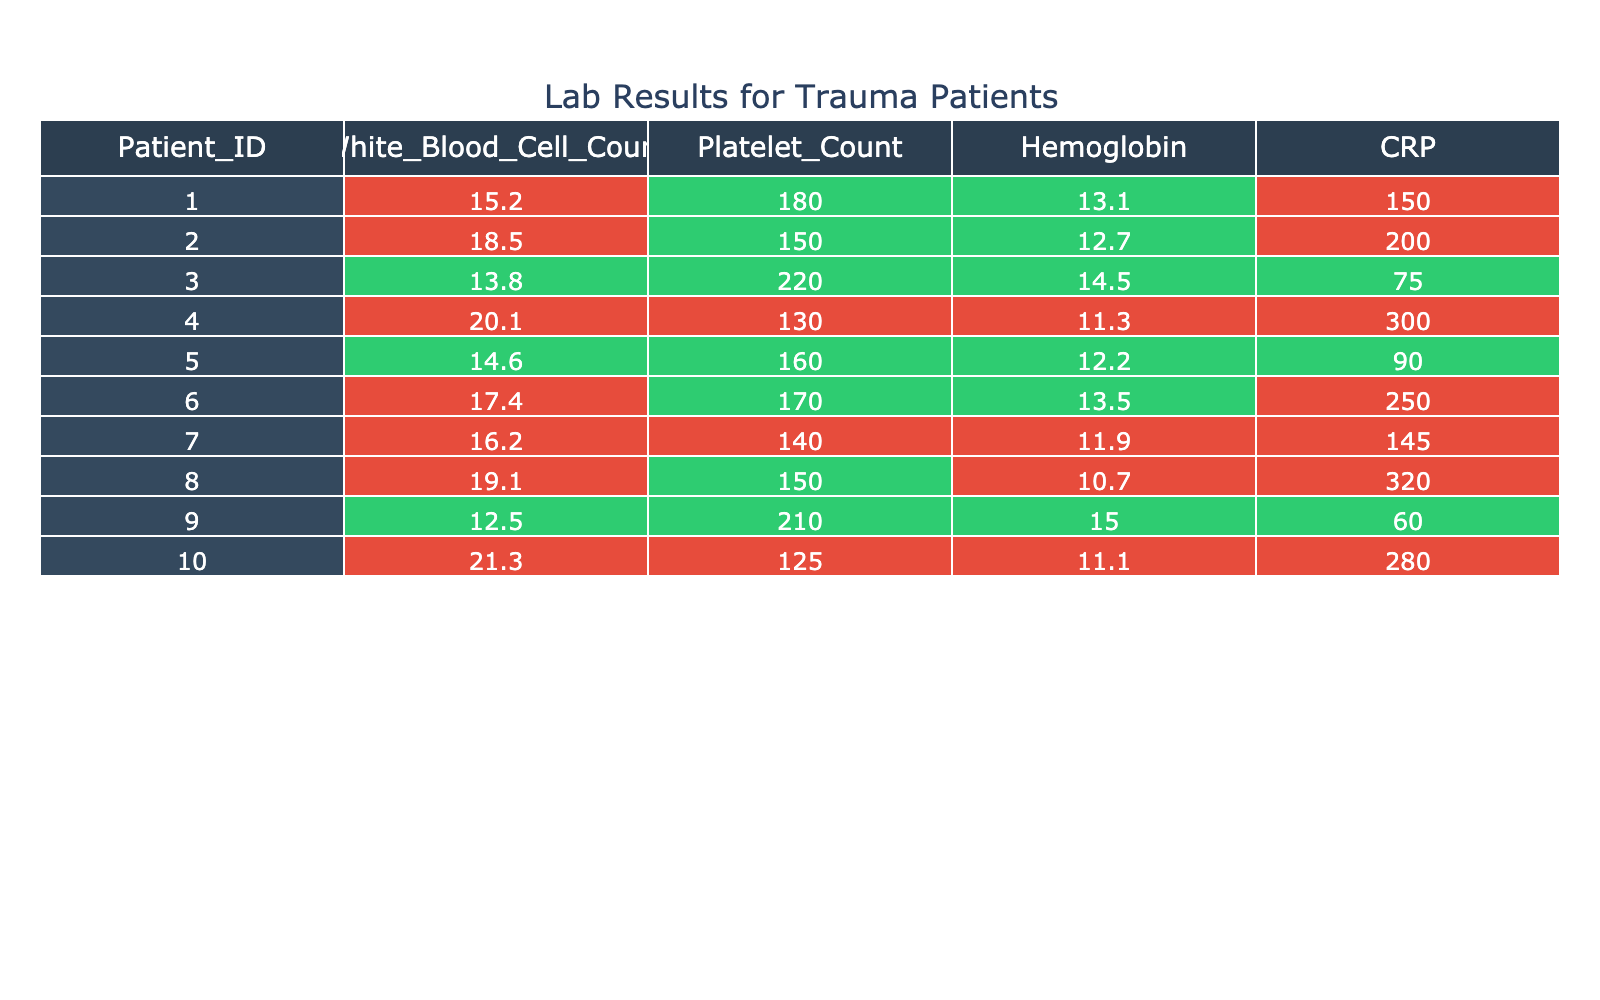What is the White Blood Cell Count for Patient ID 005? The table shows that Patient ID 005 has a White Blood Cell Count of 14.6.
Answer: 14.6 Which patient has the highest CRP value? Upon reviewing the CRP values, Patient ID 004 shows the highest value at 300.
Answer: Patient ID 004 Is there any patient with a Hemoglobin level below 12? By examining the Hemoglobin levels, I see that Patient ID 010 has a Hemoglobin level of 11.1, which is below 12.
Answer: Yes What is the average White Blood Cell Count of all patients? The White Blood Cell Counts are 15.2, 18.5, 13.8, 20.1, 14.6, 17.4, 16.2, 19.1, 12.5, and 21.3. Summing these yields 168.7. Since there are 10 patients, the average is 168.7 / 10 = 16.87.
Answer: 16.87 How many patients experienced a duration of hospitalization greater than 10 days? By checking the Duration of Hospitalization column, I find that Patients ID 002, 004, 008, and 007 have durations of hospitalization greater than 10 days, totaling 4 patients.
Answer: 4 Which infection type has the lowest White Blood Cell Count among the patients? Looking at the table, the lowest White Blood Cell Count is reported for Patient ID 009 with a count of 12.5, and this corresponds to a Urinary Tract Infection.
Answer: Urinary Tract Infection Is the Platelet Count for Patient ID 006 below the normal threshold of 150? The Platelet Count for Patient ID 006 is 170, which is not below the normal threshold of 150.
Answer: No What is the difference in CRP levels between the highest and lowest? The highest CRP value is 320 (Patient ID 008) and the lowest is 60 (Patient ID 009). The difference is 320 - 60 = 260.
Answer: 260 